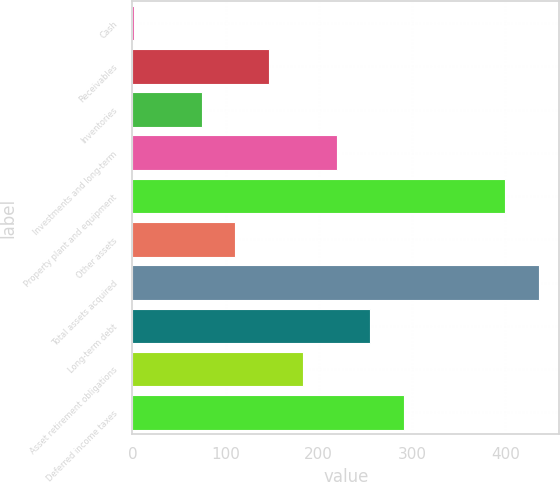Convert chart. <chart><loc_0><loc_0><loc_500><loc_500><bar_chart><fcel>Cash<fcel>Receivables<fcel>Inventories<fcel>Investments and long-term<fcel>Property plant and equipment<fcel>Other assets<fcel>Total assets acquired<fcel>Long-term debt<fcel>Asset retirement obligations<fcel>Deferred income taxes<nl><fcel>2<fcel>146.8<fcel>74.4<fcel>219.2<fcel>400.2<fcel>110.6<fcel>436.4<fcel>255.4<fcel>183<fcel>291.6<nl></chart> 